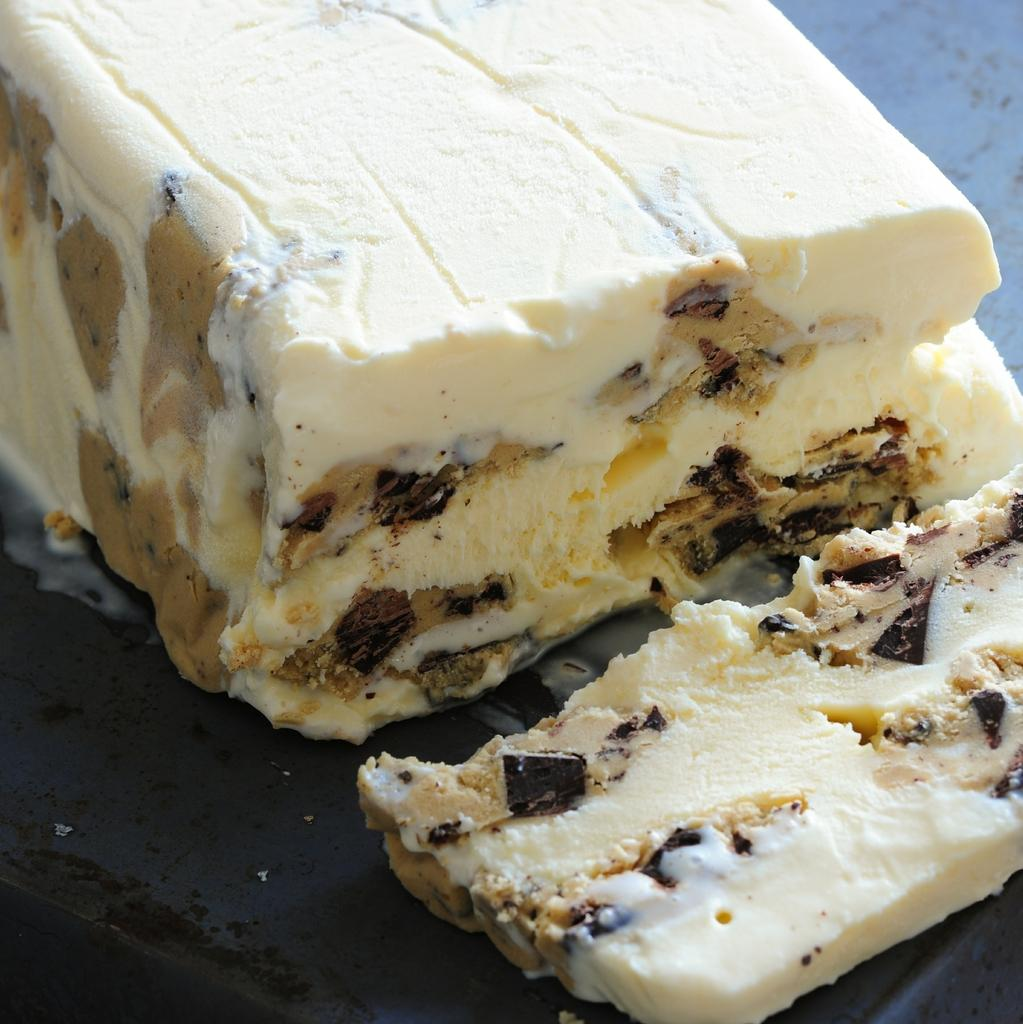What is the main subject of the image? The main subject of the image is an ice-cream. Where is the ice-cream located in the image? The ice-cream is on a surface in the image. Can you see a bear jumping over the waves in the image? No, there is no bear or waves present in the image; it only features an ice-cream on a surface. 